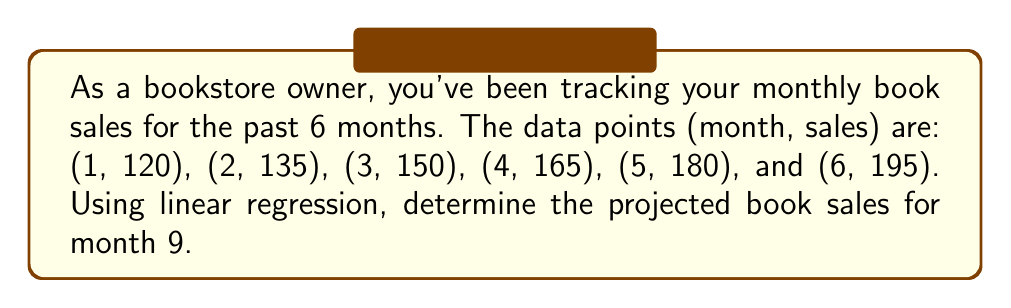Solve this math problem. To solve this problem using linear regression, we'll follow these steps:

1. Calculate the means of x (months) and y (sales):
   $\bar{x} = \frac{1+2+3+4+5+6}{6} = 3.5$
   $\bar{y} = \frac{120+135+150+165+180+195}{6} = 157.5$

2. Calculate the slope (m) using the formula:
   $m = \frac{\sum(x_i - \bar{x})(y_i - \bar{y})}{\sum(x_i - \bar{x})^2}$

   $\sum(x_i - \bar{x})(y_i - \bar{y}) = (-2.5)(-37.5) + (-1.5)(-22.5) + (-0.5)(-7.5) + (0.5)(7.5) + (1.5)(22.5) + (2.5)(37.5) = 175$

   $\sum(x_i - \bar{x})^2 = (-2.5)^2 + (-1.5)^2 + (-0.5)^2 + (0.5)^2 + (1.5)^2 + (2.5)^2 = 17.5$

   $m = \frac{175}{17.5} = 10$

3. Calculate the y-intercept (b) using the formula:
   $b = \bar{y} - m\bar{x} = 157.5 - 10(3.5) = 122.5$

4. The linear regression equation is:
   $y = mx + b = 10x + 122.5$

5. To project sales for month 9, substitute x = 9 into the equation:
   $y = 10(9) + 122.5 = 212.5$

Therefore, the projected book sales for month 9 is 212.5 books.
Answer: 212.5 books 